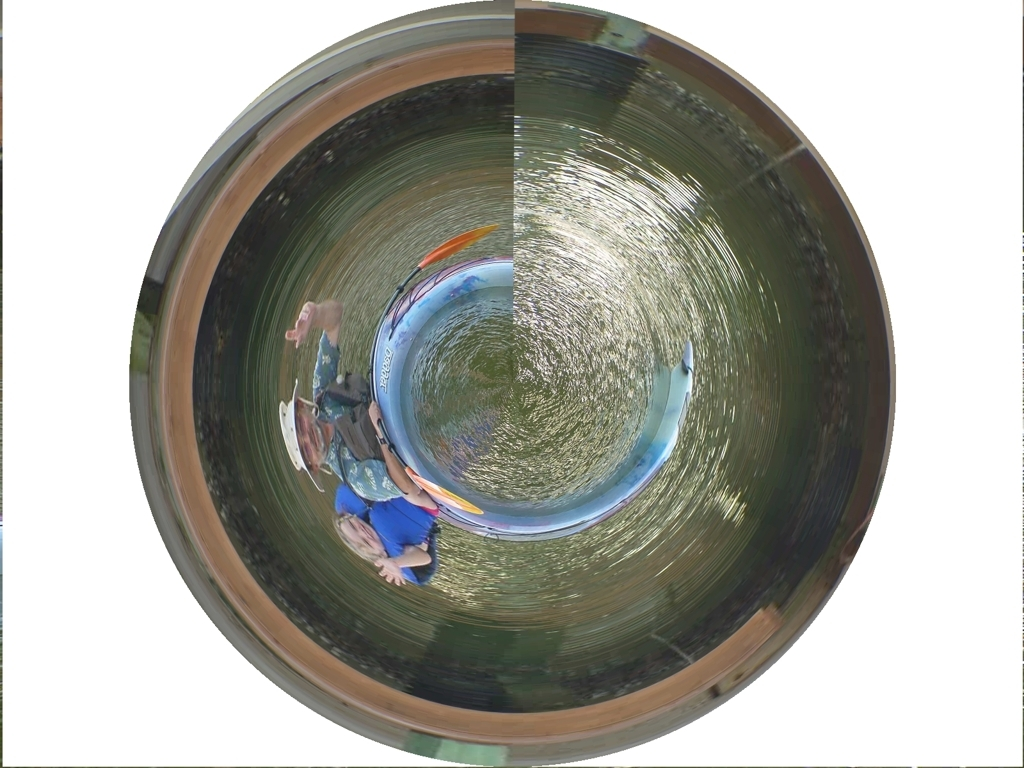Is the quality of the image average? The image quality appears to be somewhat compromised due to its unconventional circular distortion, which may affect the viewers' ability to accurately assess the content. This effect could be intentional, as part of an artistic expression, or a result of the camera lens used to capture the scene. Given these factors, the quality of the image might be seen as average, depending on the viewer's criteria for image quality. 